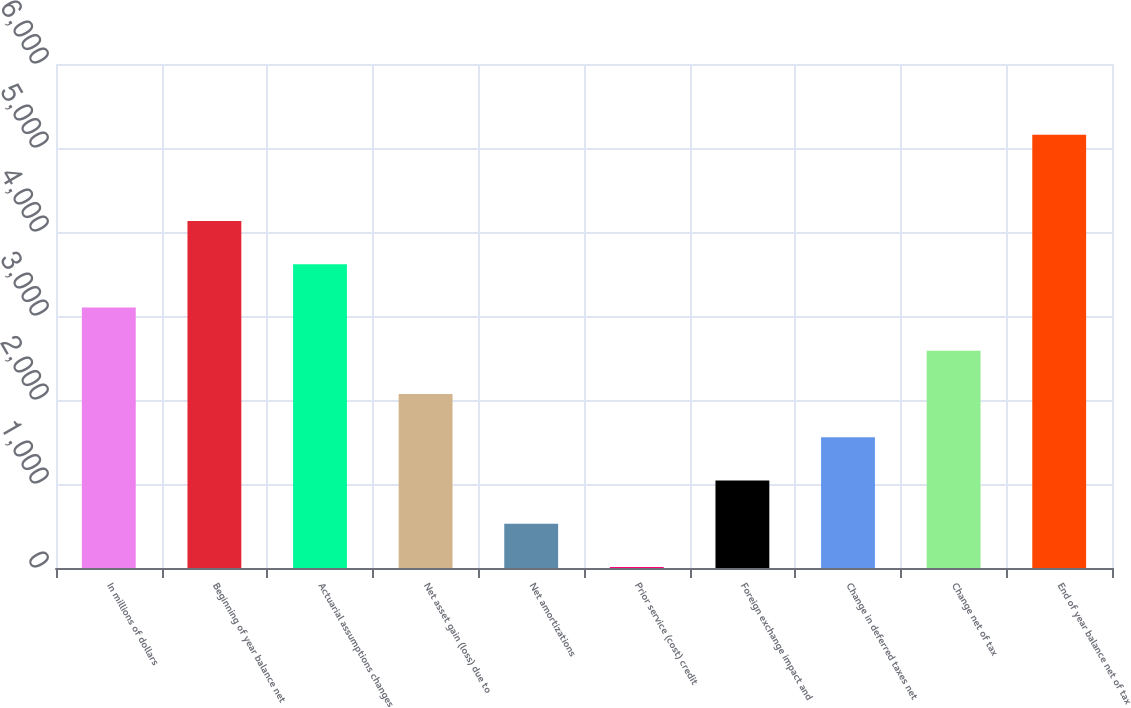Convert chart to OTSL. <chart><loc_0><loc_0><loc_500><loc_500><bar_chart><fcel>In millions of dollars<fcel>Beginning of year balance net<fcel>Actuarial assumptions changes<fcel>Net asset gain (loss) due to<fcel>Net amortizations<fcel>Prior service (cost) credit<fcel>Foreign exchange impact and<fcel>Change in deferred taxes net<fcel>Change net of tax<fcel>End of year balance net of tax<nl><fcel>3100.6<fcel>4129.8<fcel>3615.2<fcel>2071.4<fcel>527.6<fcel>13<fcel>1042.2<fcel>1556.8<fcel>2586<fcel>5159<nl></chart> 